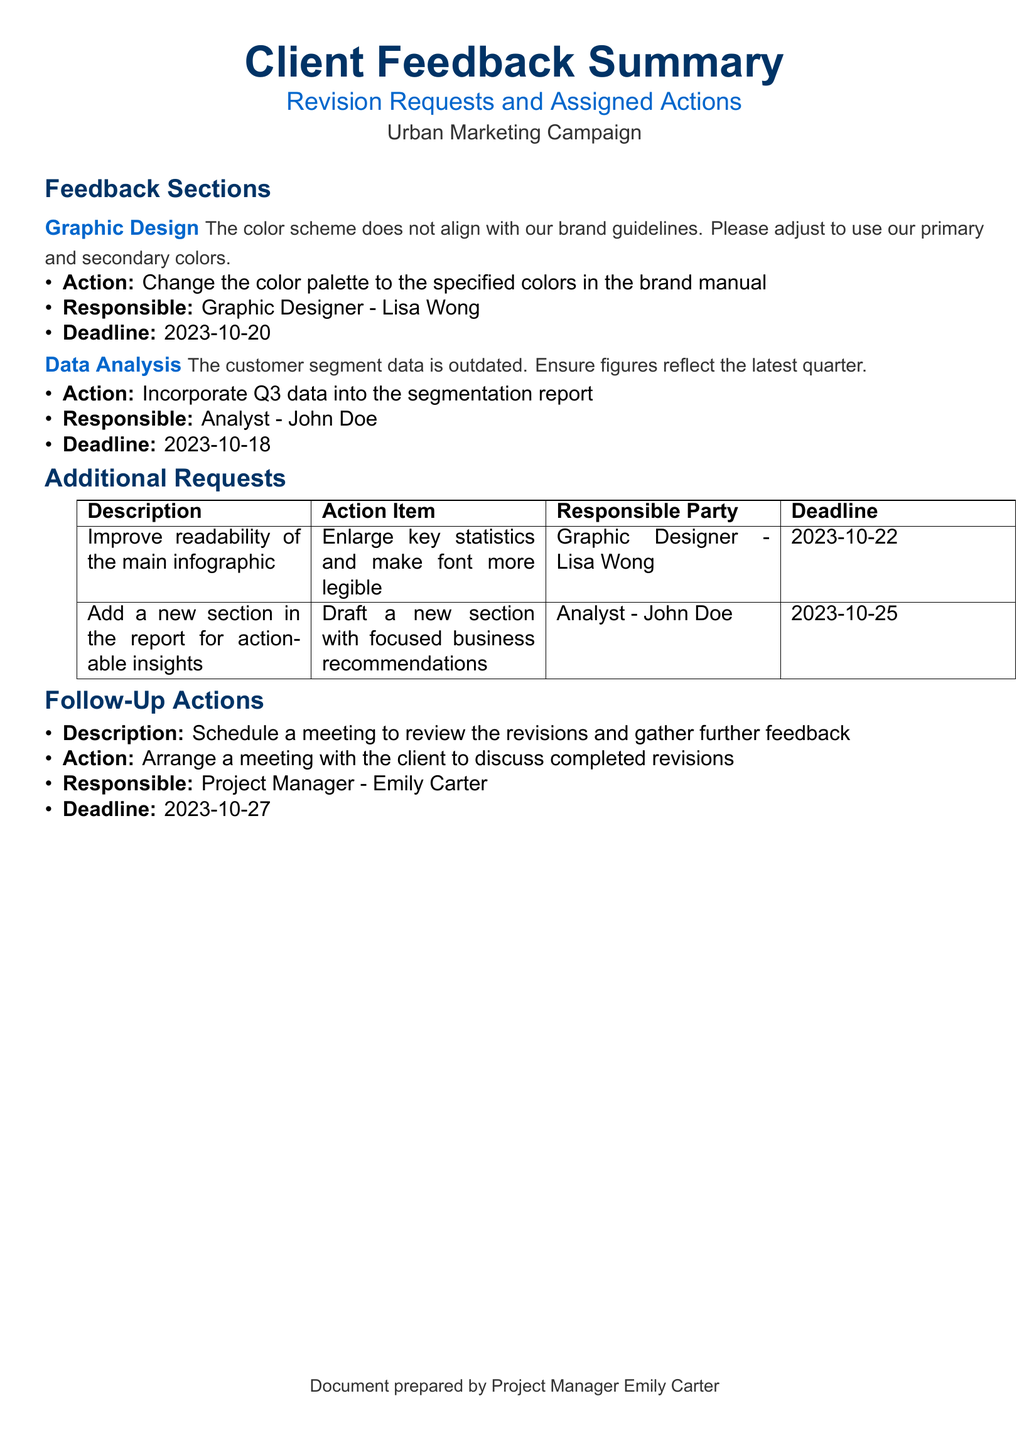What is the primary issue with the graphic design? The primary issue reported is that the color scheme does not align with the brand guidelines.
Answer: The color scheme does not align with our brand guidelines Who is responsible for changing the color palette? The document specifies Lisa Wong as the responsible graphic designer for the color palette change.
Answer: Graphic Designer - Lisa Wong What is the deadline for incorporating the Q3 data into the segmentation report? The document states that the deadline for the analyst to incorporate Q3 data is October 18, 2023.
Answer: 2023-10-18 What action is required for improving the main infographic? The action required is to enlarge key statistics and make the font more legible.
Answer: Enlarge key statistics and make font more legible When is the follow-up meeting with the client scheduled? The document indicates that the follow-up meeting should be arranged by October 27, 2023.
Answer: 2023-10-27 What is the new section added in the report focusing on? The new section in the report is focused on actionable insights and business recommendations.
Answer: Actionable insights What is the title of the document? The title denotes that it's a summary of client feedback with revision requests.
Answer: Client Feedback Summary How many additional requests are listed in the table? The table contains two additional requests listed relating to design and analysis.
Answer: Two What is the main topic of the document? The main topic revolves around the feedback summary and revision actions related to an urban marketing campaign.
Answer: Urban Marketing Campaign 